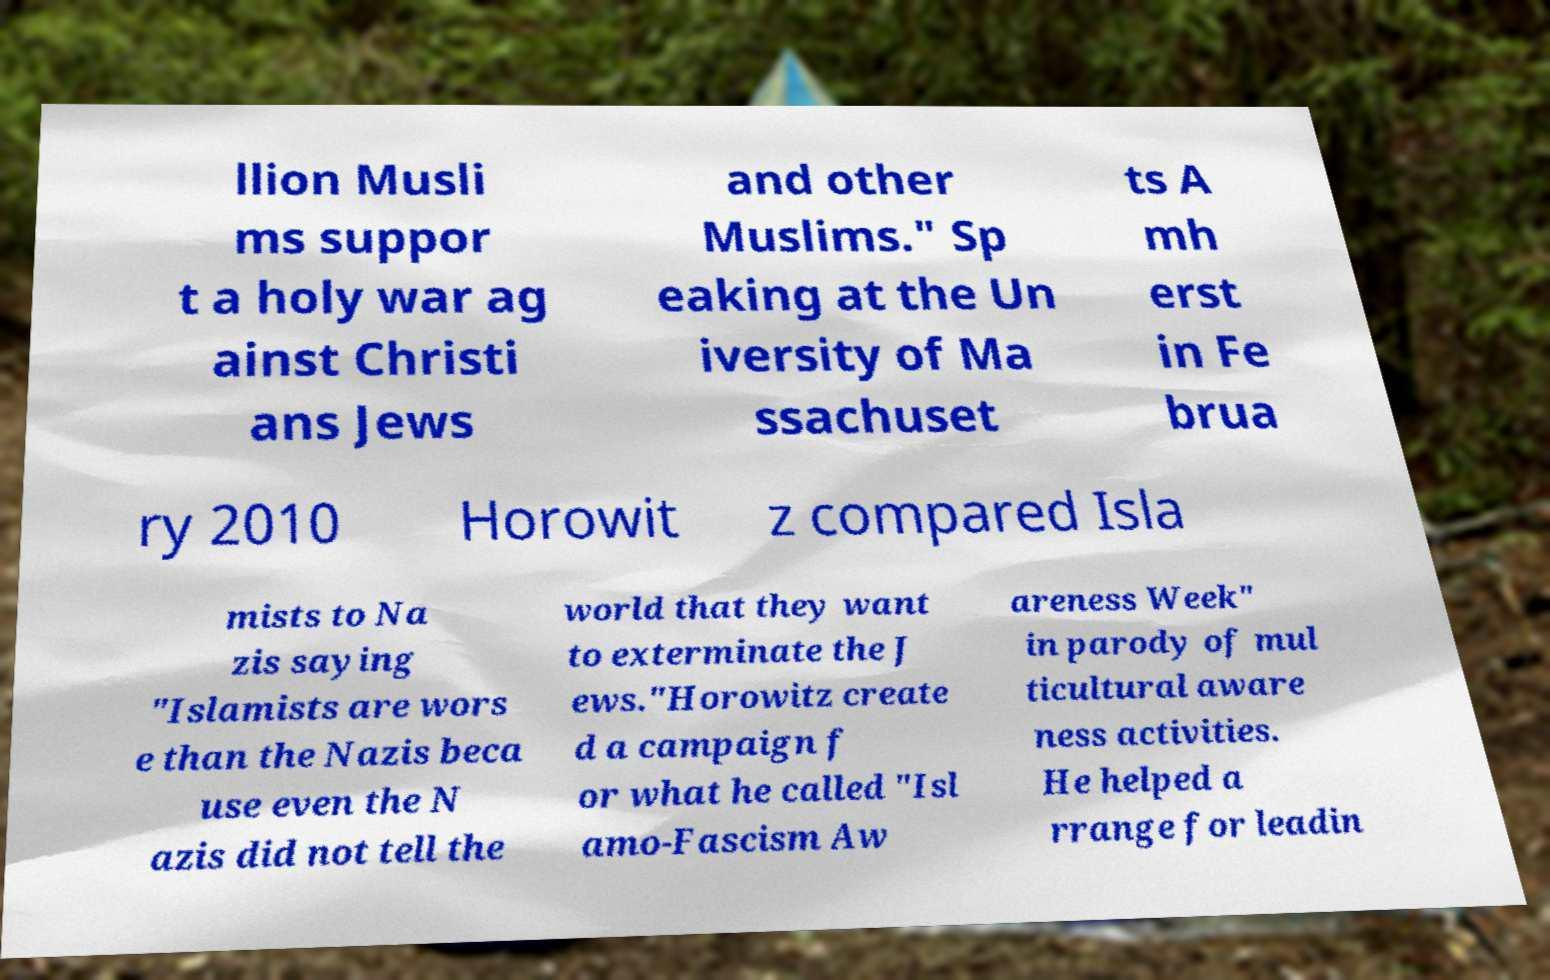Please identify and transcribe the text found in this image. llion Musli ms suppor t a holy war ag ainst Christi ans Jews and other Muslims." Sp eaking at the Un iversity of Ma ssachuset ts A mh erst in Fe brua ry 2010 Horowit z compared Isla mists to Na zis saying "Islamists are wors e than the Nazis beca use even the N azis did not tell the world that they want to exterminate the J ews."Horowitz create d a campaign f or what he called "Isl amo-Fascism Aw areness Week" in parody of mul ticultural aware ness activities. He helped a rrange for leadin 